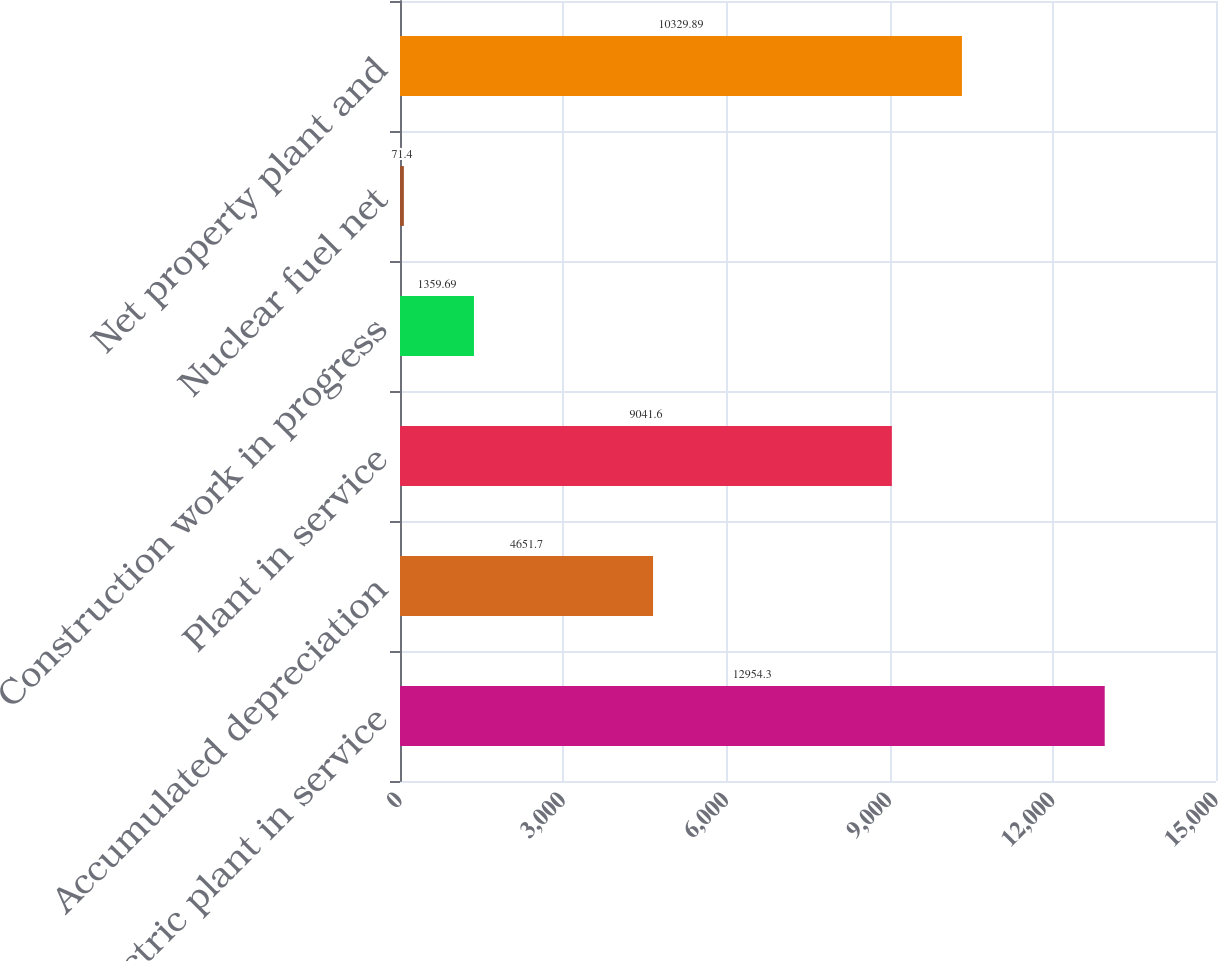<chart> <loc_0><loc_0><loc_500><loc_500><bar_chart><fcel>Electric plant in service<fcel>Accumulated depreciation<fcel>Plant in service<fcel>Construction work in progress<fcel>Nuclear fuel net<fcel>Net property plant and<nl><fcel>12954.3<fcel>4651.7<fcel>9041.6<fcel>1359.69<fcel>71.4<fcel>10329.9<nl></chart> 